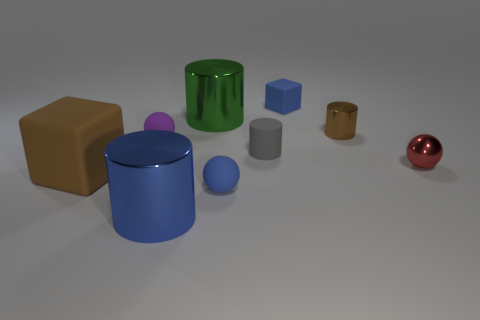Subtract all balls. How many objects are left? 6 Subtract 0 green blocks. How many objects are left? 9 Subtract all big brown metallic things. Subtract all gray things. How many objects are left? 8 Add 3 tiny gray matte things. How many tiny gray matte things are left? 4 Add 2 tiny gray matte cylinders. How many tiny gray matte cylinders exist? 3 